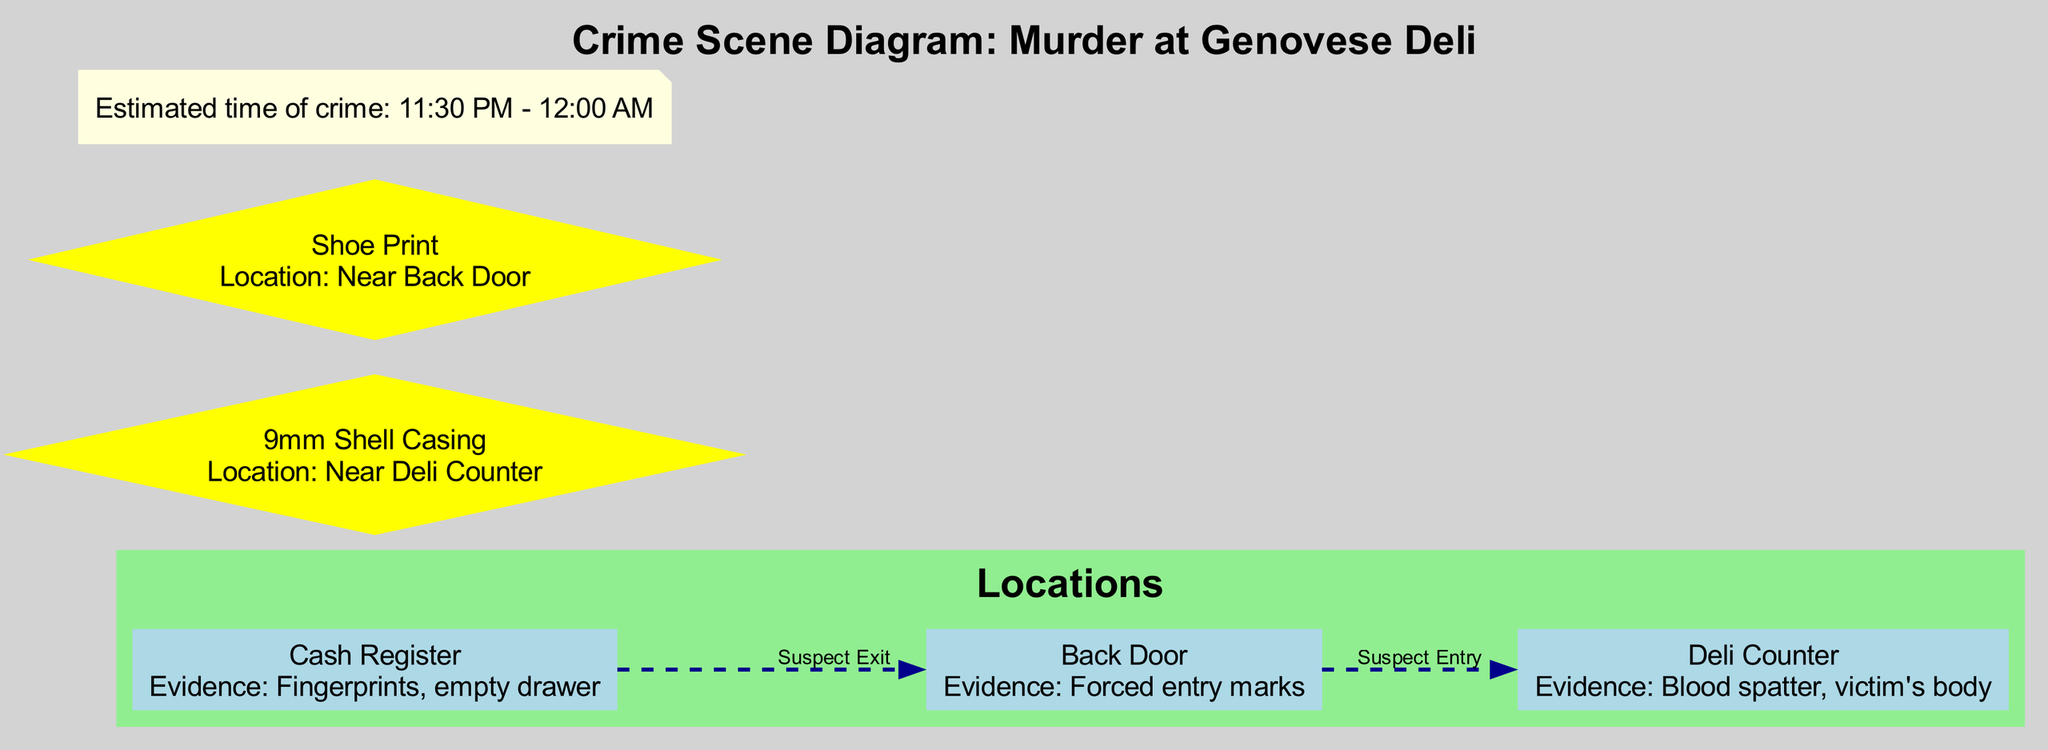What are the two main locations of evidence in the crime scene? In the diagram, the main locations of evidence are indicated as nodes. The Deli Counter contains blood spatter and the victim's body, while the Cash Register has fingerprints and an empty drawer. By identifying these specific locations as they relate to the evidence presented, we determine these two locations.
Answer: Deli Counter, Cash Register How many pieces of evidence are listed in the diagram? The diagram explicitly lists evidence in different locations. Upon reviewing all elements classified as evidence, we find that there are four distinct pieces of evidence: blood spatter, fingerprints, a 9mm shell casing, and a shoe print. Thus, the total count is derived from these elements.
Answer: 4 What type of movement does the suspect make from the Cash Register? To answer this question, we look at the diagram's movements related to the suspect's entry and exit. The suspect's movement from the Cash Register is indicated as moving towards the Back Door as they exit the scene. Thus, we ascertain the nature of the movement specified in the diagram.
Answer: Exit Where is the forced entry sign located? The diagram indicates the location of forced entry marks as being at the Back Door. By examining the evidence and where it is documented in the nodes, we find this specific location established within the context of the crime scene.
Answer: Back Door What is the estimated time of the crime? In the notes section of the diagram, there is a specific mention of the estimated time of the crime. By closely observing the note provided, we can extract this detail, stating the possible timeframe during which the crime took place.
Answer: 11:30 PM - 12:00 AM Which location contains a 9mm shell casing? Through analyzing the evidence locations in the diagram, we determine that the 9mm shell casing is located near the Deli Counter. This information is clearly outlined in the evidence presented in the diagram and corresponds to the specific location referenced.
Answer: Near Deli Counter What evidence is found near the Back Door? The diagram explicitly mentions the piece of evidence found near the Back Door. By closely checking each piece of evidence listed, we find the shoe print is indicated in relation to the Back Door. Thus, we can assert this answer reliably based on the layout.
Answer: Shoe Print What was the path of the suspect's entry? The movement of the suspect's entry is explicitly defined in the diagram, indicating that they entered the scene through the Back Door and made their way toward the Deli Counter. By following the path noted in the diagram, we can confirm the suspect's entry route.
Answer: Back Door to Deli Counter 